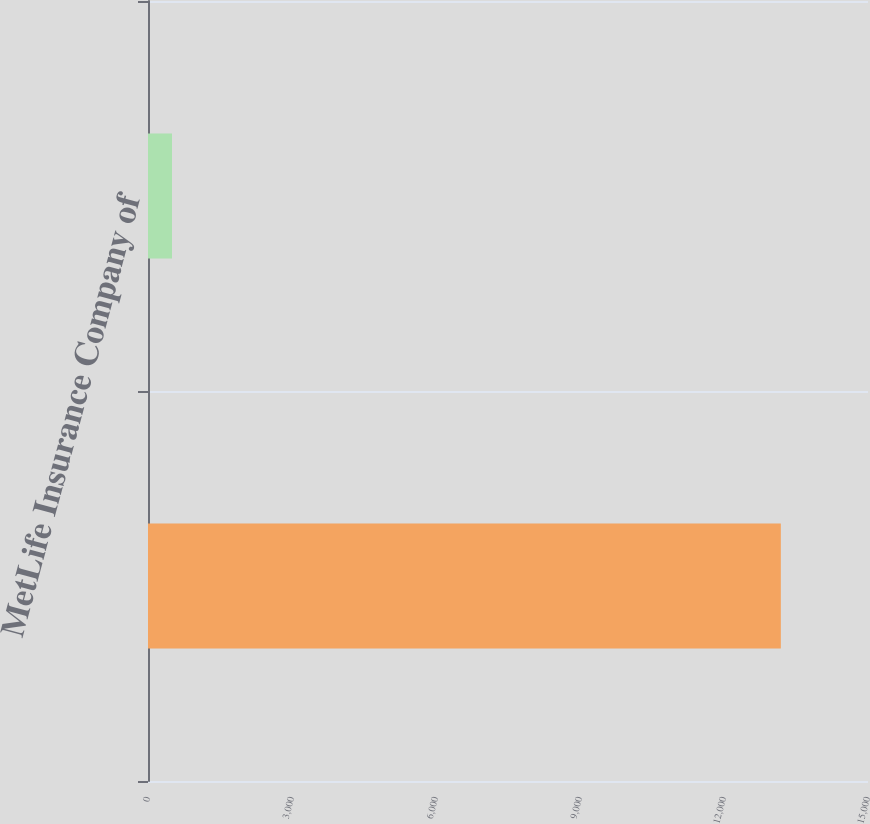<chart> <loc_0><loc_0><loc_500><loc_500><bar_chart><ecel><fcel>MetLife Insurance Company of<nl><fcel>13184<fcel>500<nl></chart> 